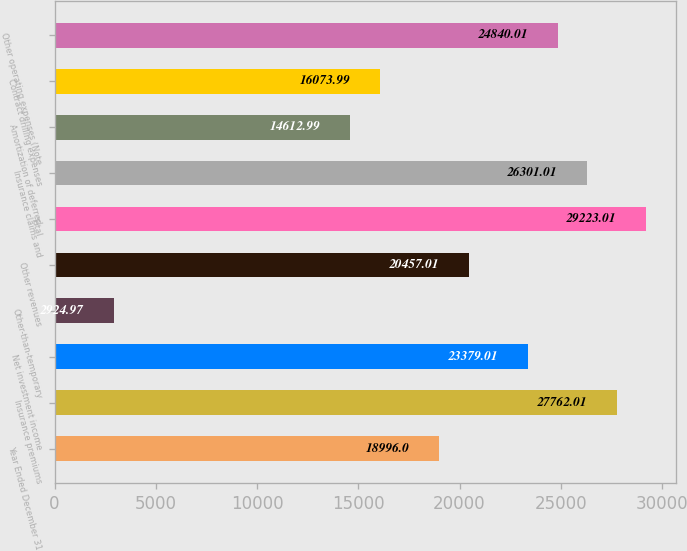<chart> <loc_0><loc_0><loc_500><loc_500><bar_chart><fcel>Year Ended December 31<fcel>Insurance premiums<fcel>Net investment income<fcel>Other-than-temporary<fcel>Other revenues<fcel>Total<fcel>Insurance claims and<fcel>Amortization of deferred<fcel>Contract drilling expenses<fcel>Other operating expenses (Note<nl><fcel>18996<fcel>27762<fcel>23379<fcel>2924.97<fcel>20457<fcel>29223<fcel>26301<fcel>14613<fcel>16074<fcel>24840<nl></chart> 